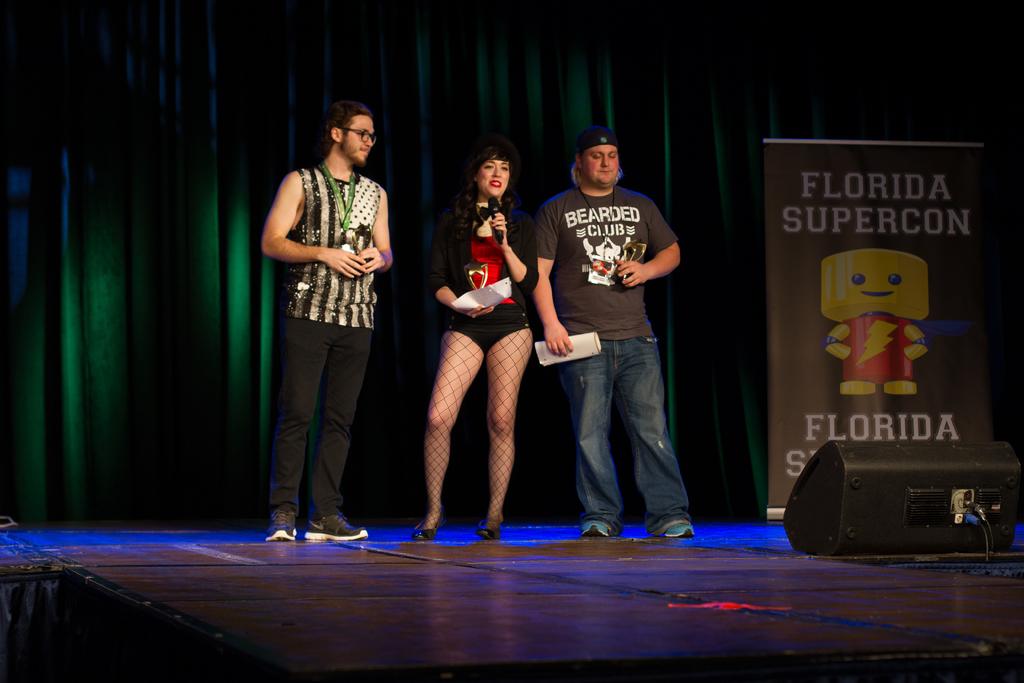What event is this?
Offer a very short reply. Florida supercon. 